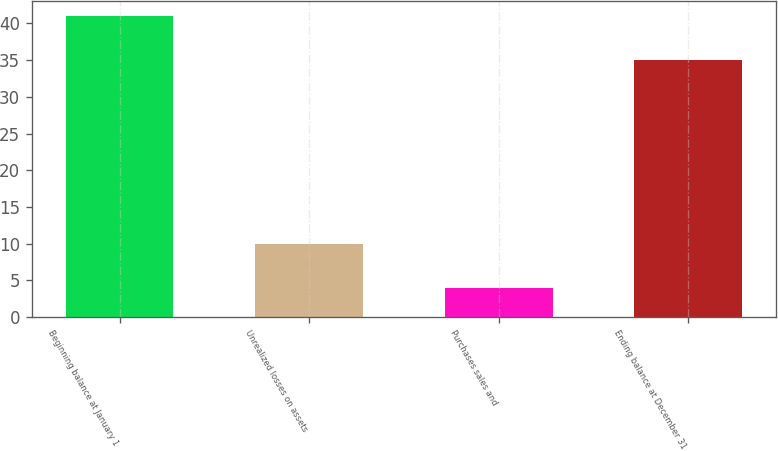<chart> <loc_0><loc_0><loc_500><loc_500><bar_chart><fcel>Beginning balance at January 1<fcel>Unrealized losses on assets<fcel>Purchases sales and<fcel>Ending balance at December 31<nl><fcel>41<fcel>10<fcel>4<fcel>35<nl></chart> 